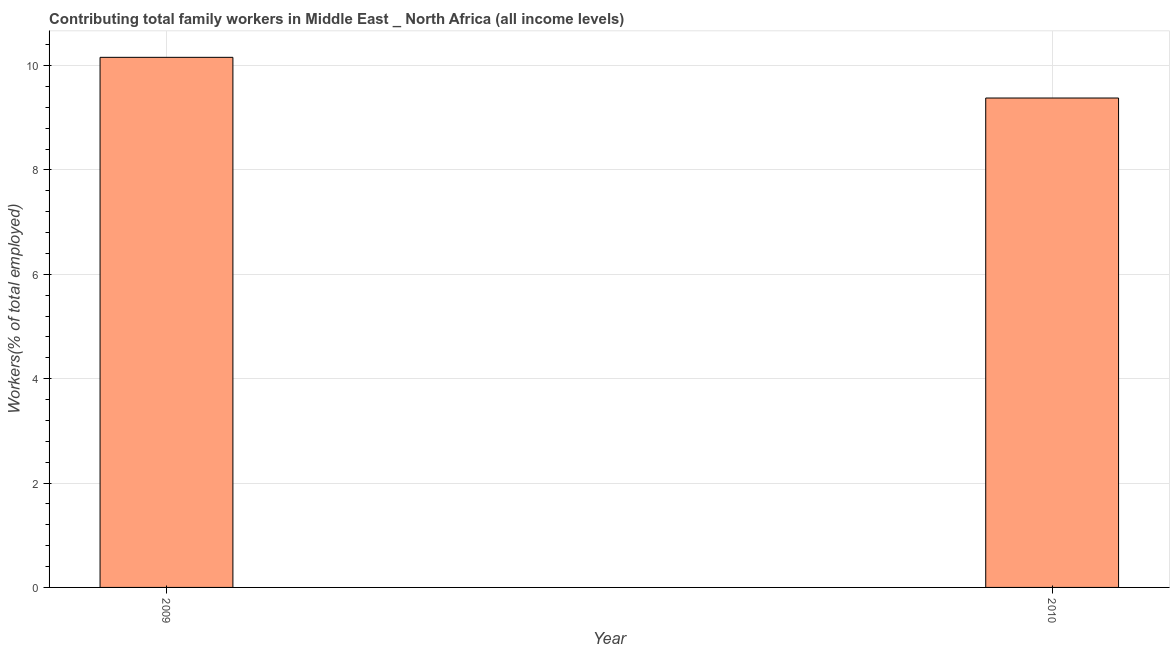Does the graph contain grids?
Offer a terse response. Yes. What is the title of the graph?
Offer a terse response. Contributing total family workers in Middle East _ North Africa (all income levels). What is the label or title of the X-axis?
Offer a very short reply. Year. What is the label or title of the Y-axis?
Give a very brief answer. Workers(% of total employed). What is the contributing family workers in 2009?
Keep it short and to the point. 10.16. Across all years, what is the maximum contributing family workers?
Your response must be concise. 10.16. Across all years, what is the minimum contributing family workers?
Your response must be concise. 9.38. In which year was the contributing family workers maximum?
Offer a very short reply. 2009. What is the sum of the contributing family workers?
Your answer should be very brief. 19.54. What is the difference between the contributing family workers in 2009 and 2010?
Your answer should be compact. 0.78. What is the average contributing family workers per year?
Offer a terse response. 9.77. What is the median contributing family workers?
Offer a terse response. 9.77. In how many years, is the contributing family workers greater than 1.2 %?
Your answer should be compact. 2. Do a majority of the years between 2009 and 2010 (inclusive) have contributing family workers greater than 2.4 %?
Provide a succinct answer. Yes. What is the ratio of the contributing family workers in 2009 to that in 2010?
Your answer should be compact. 1.08. In how many years, is the contributing family workers greater than the average contributing family workers taken over all years?
Provide a succinct answer. 1. How many bars are there?
Provide a short and direct response. 2. Are all the bars in the graph horizontal?
Your response must be concise. No. How many years are there in the graph?
Offer a terse response. 2. What is the difference between two consecutive major ticks on the Y-axis?
Your answer should be compact. 2. Are the values on the major ticks of Y-axis written in scientific E-notation?
Make the answer very short. No. What is the Workers(% of total employed) of 2009?
Your answer should be compact. 10.16. What is the Workers(% of total employed) in 2010?
Give a very brief answer. 9.38. What is the difference between the Workers(% of total employed) in 2009 and 2010?
Give a very brief answer. 0.78. What is the ratio of the Workers(% of total employed) in 2009 to that in 2010?
Make the answer very short. 1.08. 